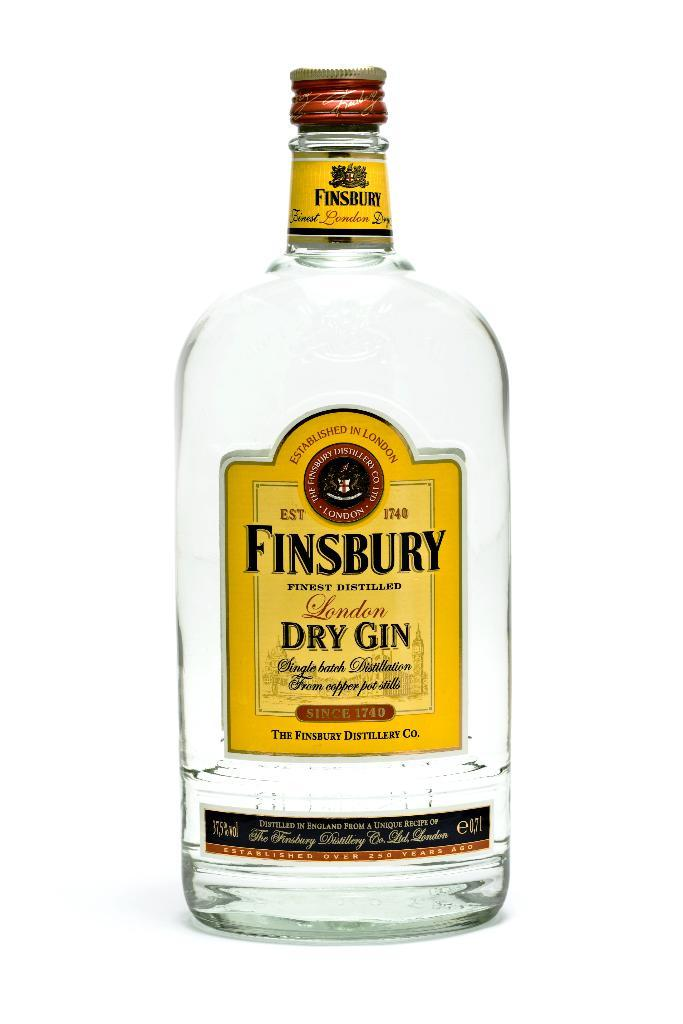<image>
Offer a succinct explanation of the picture presented. an alcohol bottle with the word Finsbury on it 